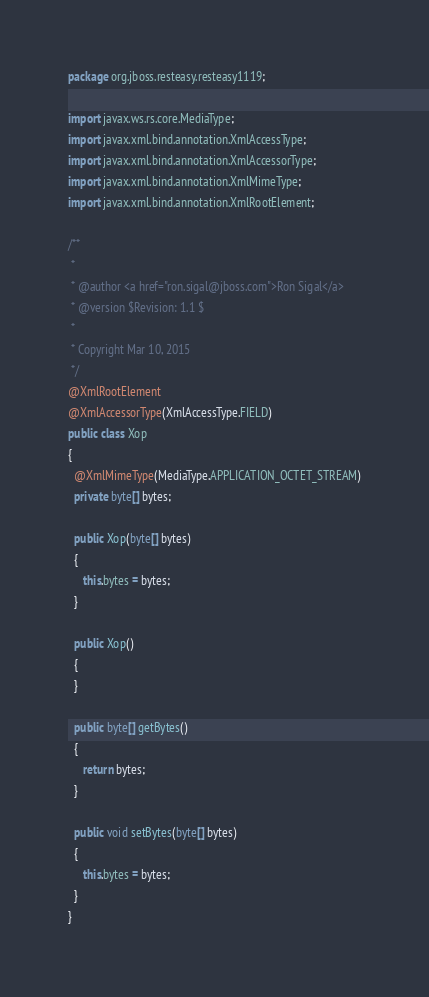<code> <loc_0><loc_0><loc_500><loc_500><_Java_>package org.jboss.resteasy.resteasy1119;

import javax.ws.rs.core.MediaType;
import javax.xml.bind.annotation.XmlAccessType;
import javax.xml.bind.annotation.XmlAccessorType;
import javax.xml.bind.annotation.XmlMimeType;
import javax.xml.bind.annotation.XmlRootElement;

/**
 * 
 * @author <a href="ron.sigal@jboss.com">Ron Sigal</a>
 * @version $Revision: 1.1 $
 *
 * Copyright Mar 10, 2015
 */
@XmlRootElement
@XmlAccessorType(XmlAccessType.FIELD)
public class Xop
{
  @XmlMimeType(MediaType.APPLICATION_OCTET_STREAM)
  private byte[] bytes;

  public Xop(byte[] bytes)
  {
     this.bytes = bytes;
  }
  
  public Xop()
  {
  }
  
  public byte[] getBytes()
  {
     return bytes;
  }
  
  public void setBytes(byte[] bytes)
  {
     this.bytes = bytes;
  }
}
</code> 